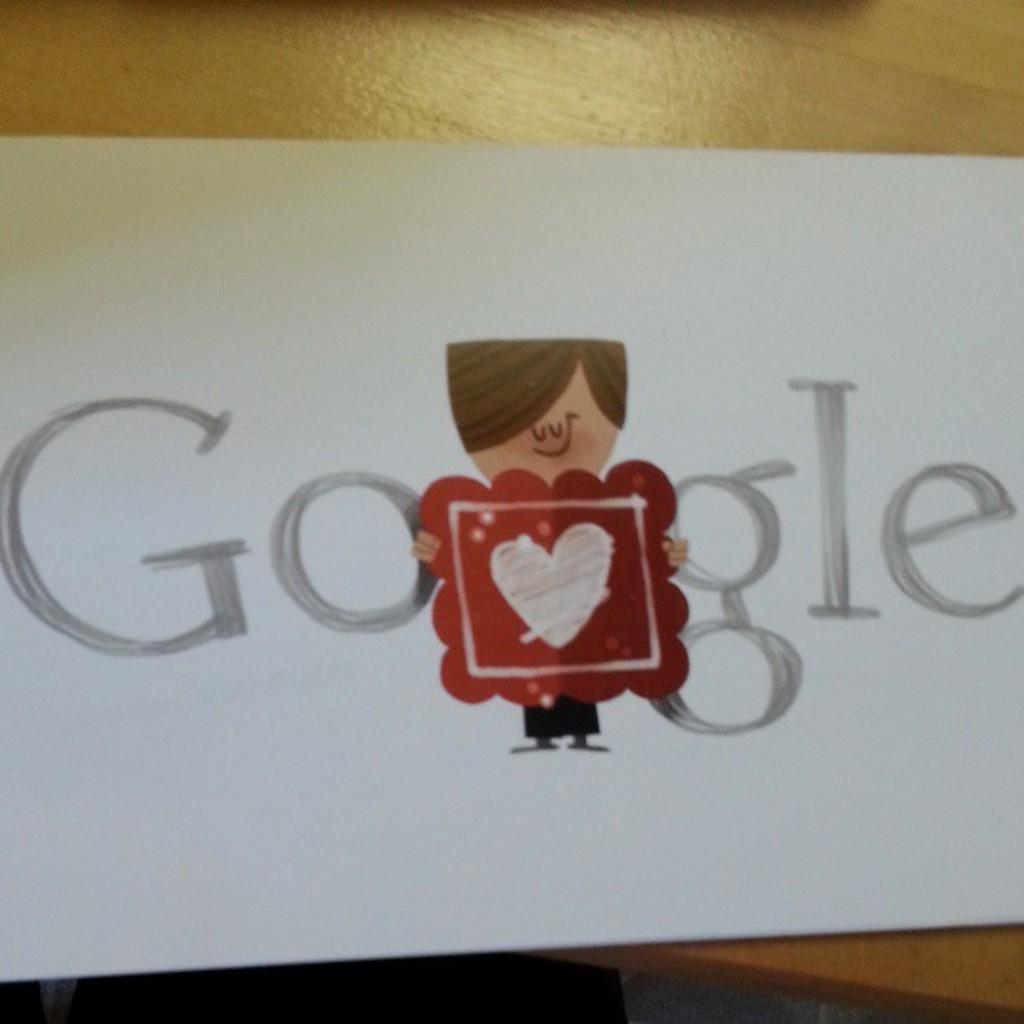What is depicted on the paper in the image? There is text and a cartoon image on a paper in the image. Where is the paper located in the image? The paper is in the center of the image. What is the main object in the image? The main object in the image is a table. Where is the paper placed in the image? The paper is on the table. How does the rainstorm affect the text on the paper in the image? There is no rainstorm present in the image, so it cannot affect the text on the paper. 